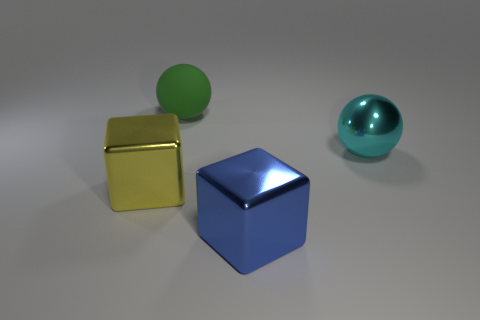Are there any large cyan objects of the same shape as the large yellow metal thing?
Your answer should be compact. No. What number of things are balls that are in front of the big green thing or big brown matte cylinders?
Keep it short and to the point. 1. Is the color of the block behind the blue metal thing the same as the object that is in front of the yellow thing?
Ensure brevity in your answer.  No. The yellow shiny cube is what size?
Ensure brevity in your answer.  Large. What number of small objects are either cyan metal balls or metallic things?
Make the answer very short. 0. What is the color of the other block that is the same size as the yellow metallic block?
Ensure brevity in your answer.  Blue. What number of other objects are the same shape as the green object?
Offer a terse response. 1. Are there any large yellow cubes made of the same material as the large blue object?
Your answer should be compact. Yes. Do the thing that is in front of the big yellow object and the big ball to the right of the green rubber object have the same material?
Your answer should be very brief. Yes. How many cyan shiny objects are there?
Your answer should be very brief. 1. 